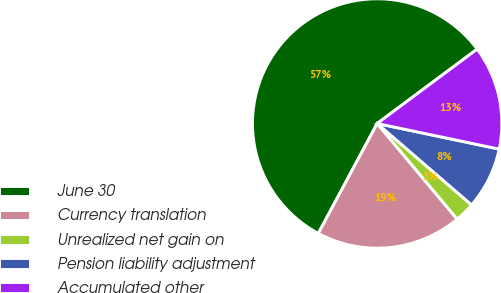Convert chart. <chart><loc_0><loc_0><loc_500><loc_500><pie_chart><fcel>June 30<fcel>Currency translation<fcel>Unrealized net gain on<fcel>Pension liability adjustment<fcel>Accumulated other<nl><fcel>56.99%<fcel>18.91%<fcel>2.59%<fcel>8.03%<fcel>13.47%<nl></chart> 